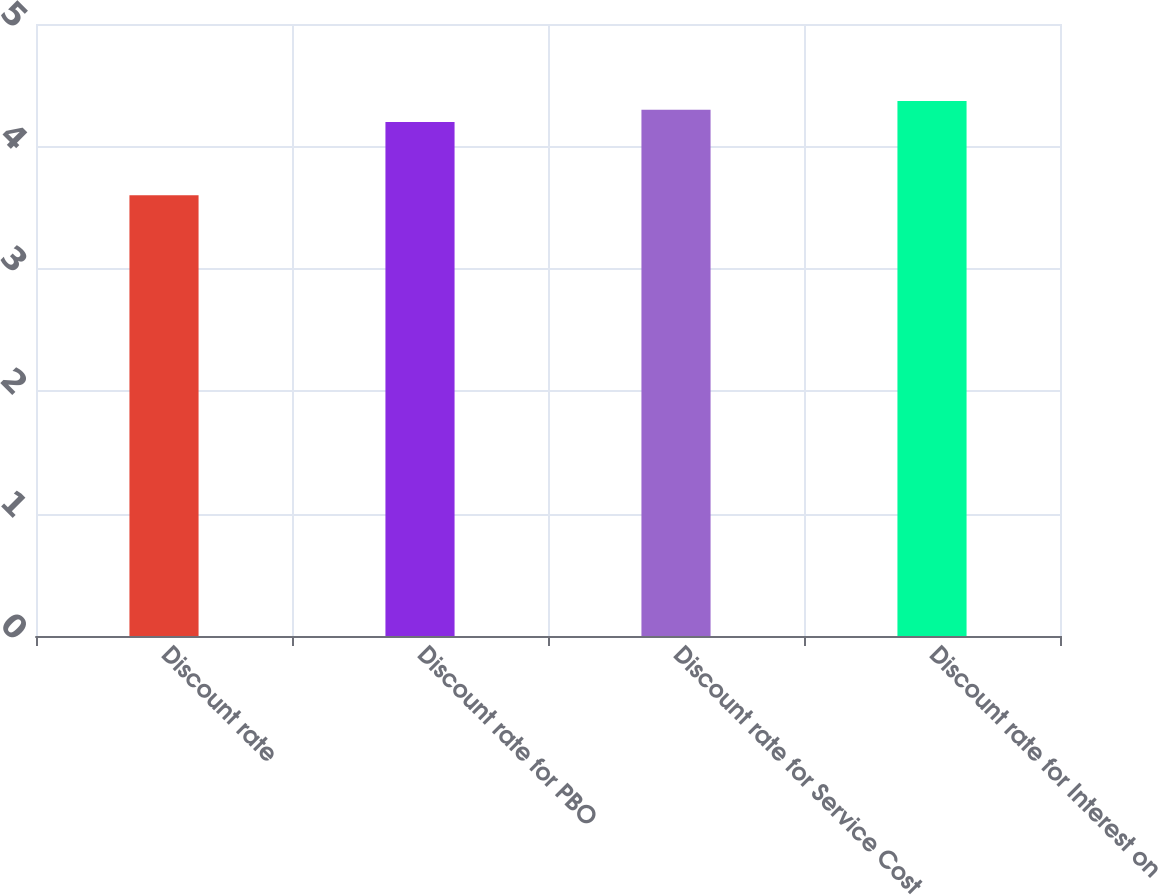<chart> <loc_0><loc_0><loc_500><loc_500><bar_chart><fcel>Discount rate<fcel>Discount rate for PBO<fcel>Discount rate for Service Cost<fcel>Discount rate for Interest on<nl><fcel>3.6<fcel>4.2<fcel>4.3<fcel>4.37<nl></chart> 